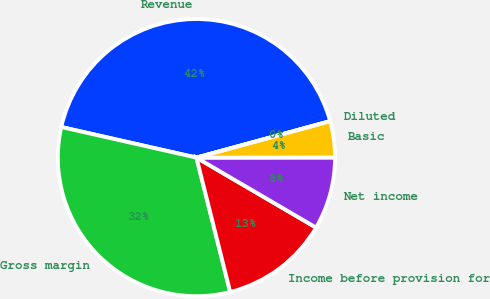Convert chart. <chart><loc_0><loc_0><loc_500><loc_500><pie_chart><fcel>Revenue<fcel>Gross margin<fcel>Income before provision for<fcel>Net income<fcel>Basic<fcel>Diluted<nl><fcel>42.22%<fcel>32.46%<fcel>12.66%<fcel>8.44%<fcel>4.22%<fcel>0.0%<nl></chart> 